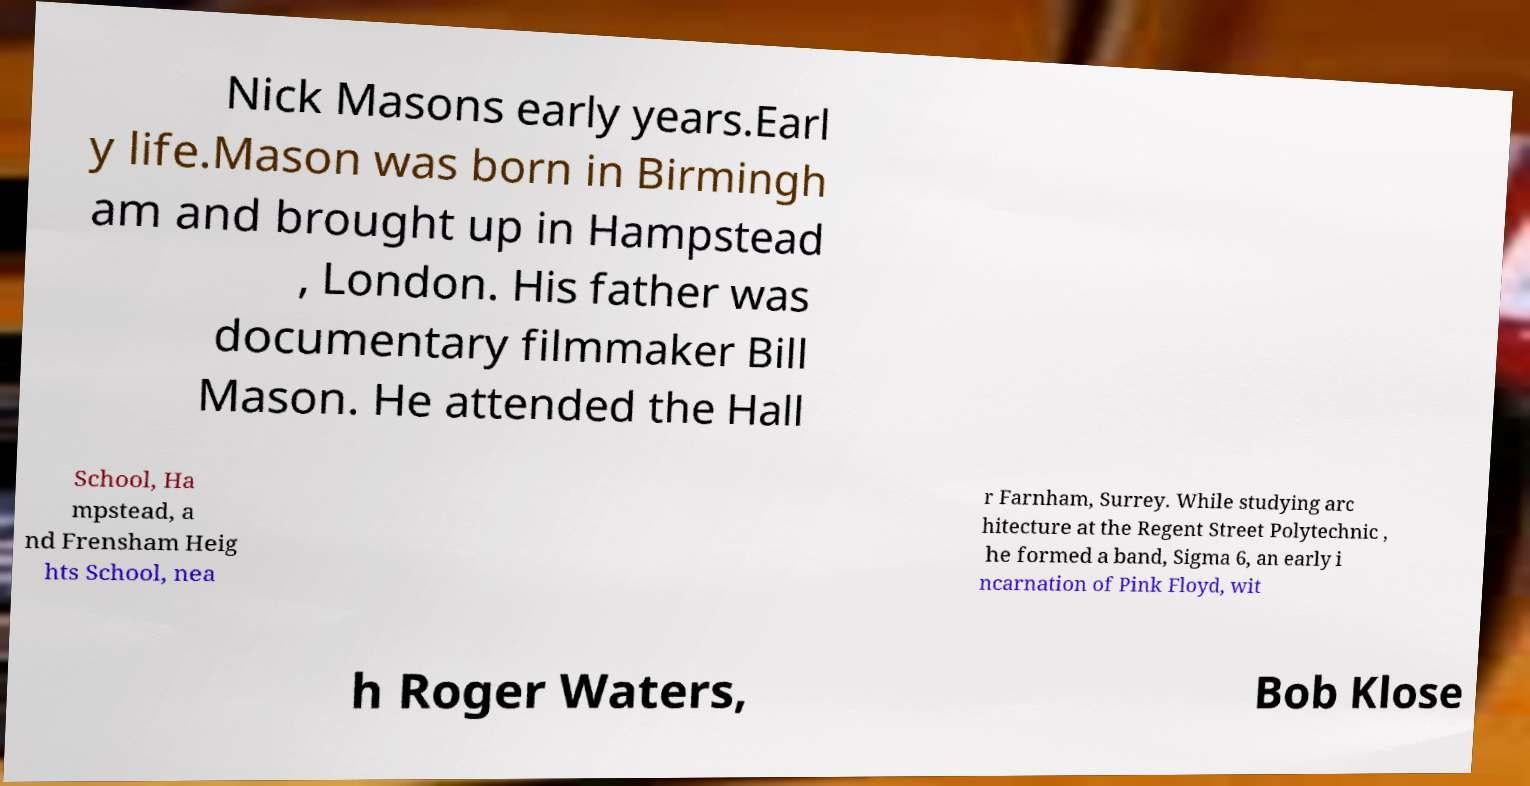For documentation purposes, I need the text within this image transcribed. Could you provide that? Nick Masons early years.Earl y life.Mason was born in Birmingh am and brought up in Hampstead , London. His father was documentary filmmaker Bill Mason. He attended the Hall School, Ha mpstead, a nd Frensham Heig hts School, nea r Farnham, Surrey. While studying arc hitecture at the Regent Street Polytechnic , he formed a band, Sigma 6, an early i ncarnation of Pink Floyd, wit h Roger Waters, Bob Klose 